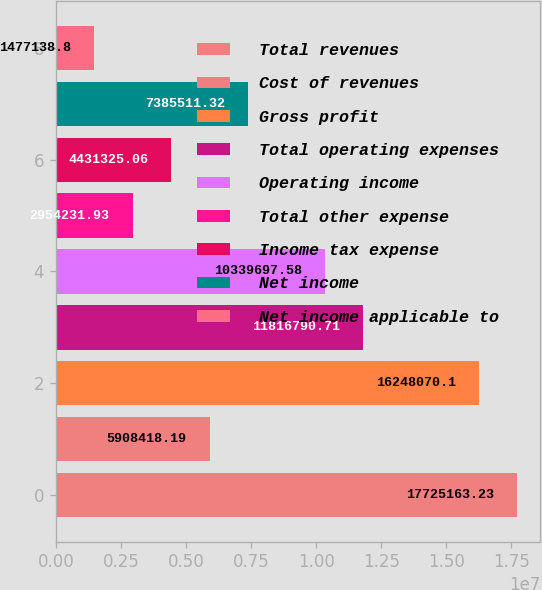<chart> <loc_0><loc_0><loc_500><loc_500><bar_chart><fcel>Total revenues<fcel>Cost of revenues<fcel>Gross profit<fcel>Total operating expenses<fcel>Operating income<fcel>Total other expense<fcel>Income tax expense<fcel>Net income<fcel>Net income applicable to<nl><fcel>1.77252e+07<fcel>5.90842e+06<fcel>1.62481e+07<fcel>1.18168e+07<fcel>1.03397e+07<fcel>2.95423e+06<fcel>4.43133e+06<fcel>7.38551e+06<fcel>1.47714e+06<nl></chart> 